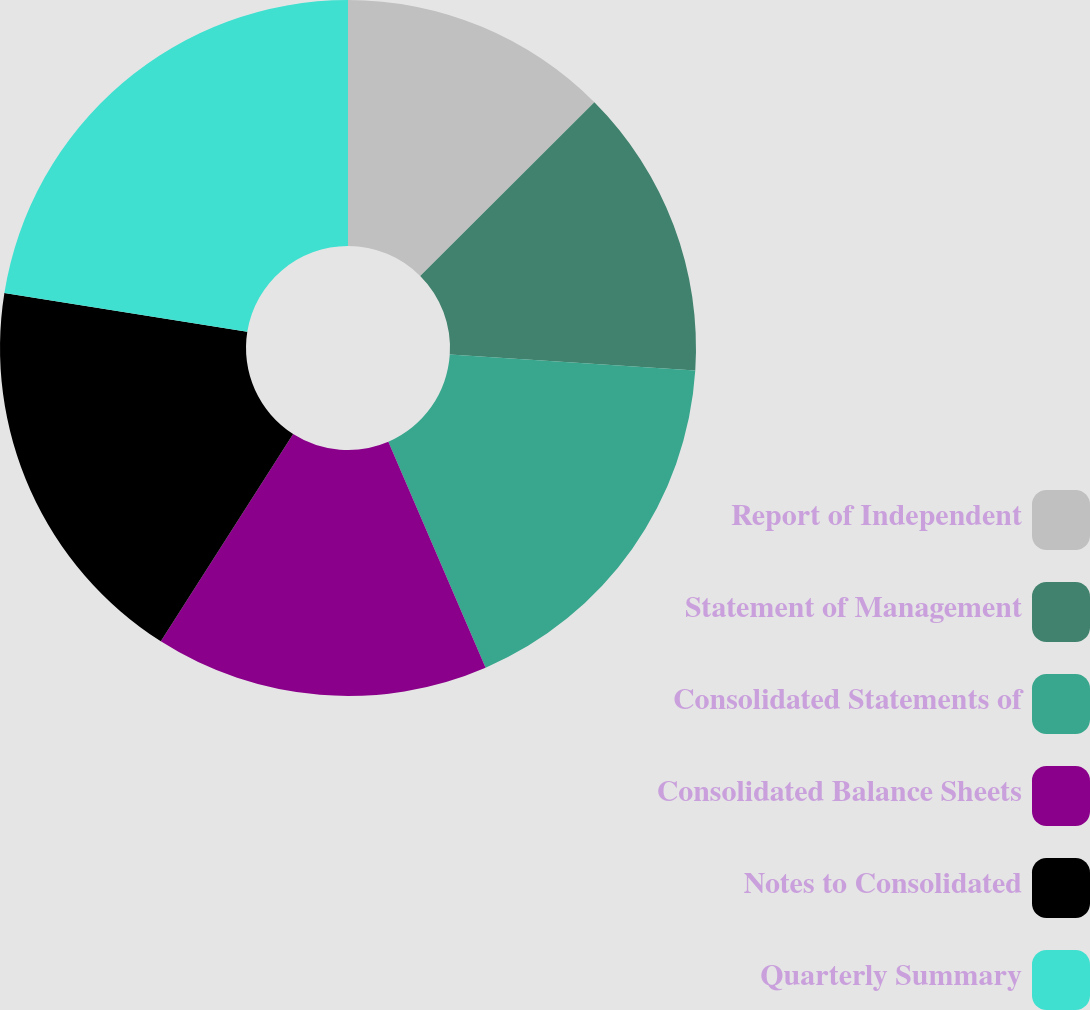<chart> <loc_0><loc_0><loc_500><loc_500><pie_chart><fcel>Report of Independent<fcel>Statement of Management<fcel>Consolidated Statements of<fcel>Consolidated Balance Sheets<fcel>Notes to Consolidated<fcel>Quarterly Summary<nl><fcel>12.52%<fcel>13.51%<fcel>17.5%<fcel>15.51%<fcel>18.49%<fcel>22.47%<nl></chart> 